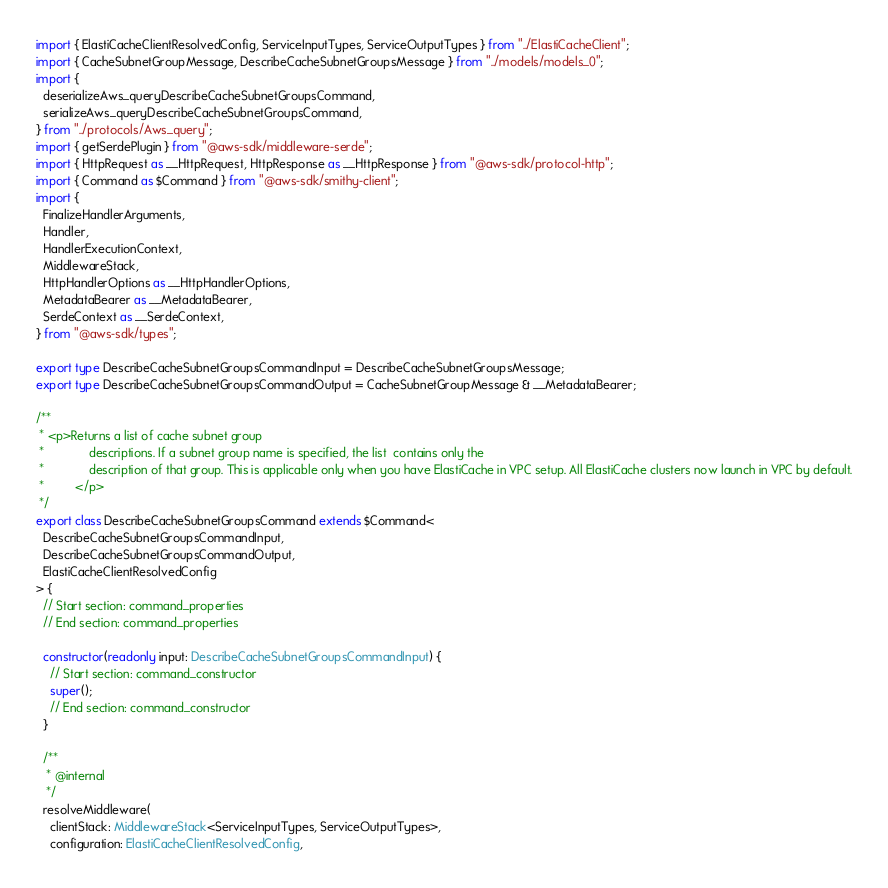<code> <loc_0><loc_0><loc_500><loc_500><_TypeScript_>import { ElastiCacheClientResolvedConfig, ServiceInputTypes, ServiceOutputTypes } from "../ElastiCacheClient";
import { CacheSubnetGroupMessage, DescribeCacheSubnetGroupsMessage } from "../models/models_0";
import {
  deserializeAws_queryDescribeCacheSubnetGroupsCommand,
  serializeAws_queryDescribeCacheSubnetGroupsCommand,
} from "../protocols/Aws_query";
import { getSerdePlugin } from "@aws-sdk/middleware-serde";
import { HttpRequest as __HttpRequest, HttpResponse as __HttpResponse } from "@aws-sdk/protocol-http";
import { Command as $Command } from "@aws-sdk/smithy-client";
import {
  FinalizeHandlerArguments,
  Handler,
  HandlerExecutionContext,
  MiddlewareStack,
  HttpHandlerOptions as __HttpHandlerOptions,
  MetadataBearer as __MetadataBearer,
  SerdeContext as __SerdeContext,
} from "@aws-sdk/types";

export type DescribeCacheSubnetGroupsCommandInput = DescribeCacheSubnetGroupsMessage;
export type DescribeCacheSubnetGroupsCommandOutput = CacheSubnetGroupMessage & __MetadataBearer;

/**
 * <p>Returns a list of cache subnet group
 *             descriptions. If a subnet group name is specified, the list  contains only the
 *             description of that group. This is applicable only when you have ElastiCache in VPC setup. All ElastiCache clusters now launch in VPC by default.
 *         </p>
 */
export class DescribeCacheSubnetGroupsCommand extends $Command<
  DescribeCacheSubnetGroupsCommandInput,
  DescribeCacheSubnetGroupsCommandOutput,
  ElastiCacheClientResolvedConfig
> {
  // Start section: command_properties
  // End section: command_properties

  constructor(readonly input: DescribeCacheSubnetGroupsCommandInput) {
    // Start section: command_constructor
    super();
    // End section: command_constructor
  }

  /**
   * @internal
   */
  resolveMiddleware(
    clientStack: MiddlewareStack<ServiceInputTypes, ServiceOutputTypes>,
    configuration: ElastiCacheClientResolvedConfig,</code> 